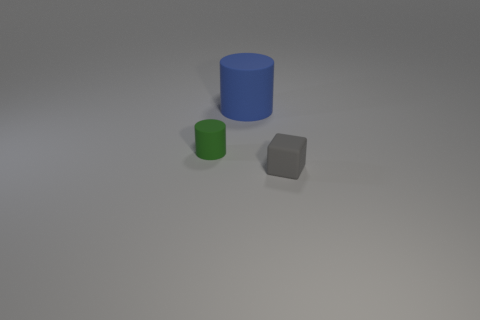Is there anything else that is the same size as the blue matte thing?
Your answer should be very brief. No. There is a green object that is the same size as the gray rubber block; what is its material?
Your answer should be very brief. Rubber. What number of other big objects have the same shape as the green object?
Make the answer very short. 1. There is a green object that is made of the same material as the gray block; what is its size?
Give a very brief answer. Small. What is the object that is behind the gray rubber thing and in front of the large object made of?
Your response must be concise. Rubber. How many green rubber objects have the same size as the blue matte cylinder?
Your response must be concise. 0. There is another small thing that is the same shape as the blue rubber thing; what material is it?
Provide a short and direct response. Rubber. How many objects are either small things that are right of the big blue thing or small matte objects to the left of the gray rubber object?
Your answer should be compact. 2. Does the gray thing have the same shape as the tiny matte thing that is left of the big rubber object?
Your answer should be compact. No. What shape is the tiny matte thing that is right of the rubber cylinder behind the small thing behind the gray rubber object?
Your answer should be very brief. Cube. 